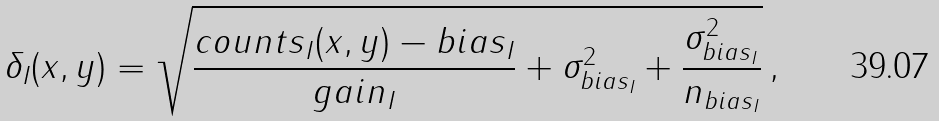<formula> <loc_0><loc_0><loc_500><loc_500>\delta _ { I } ( x , y ) = \sqrt { \frac { c o u n t s _ { I } ( x , y ) - b i a s _ { I } } { g a i n _ { I } } + \sigma _ { b i a s _ { I } } ^ { 2 } + \frac { \sigma _ { b i a s _ { I } } ^ { 2 } } { n _ { b i a s _ { I } } } } \, ,</formula> 